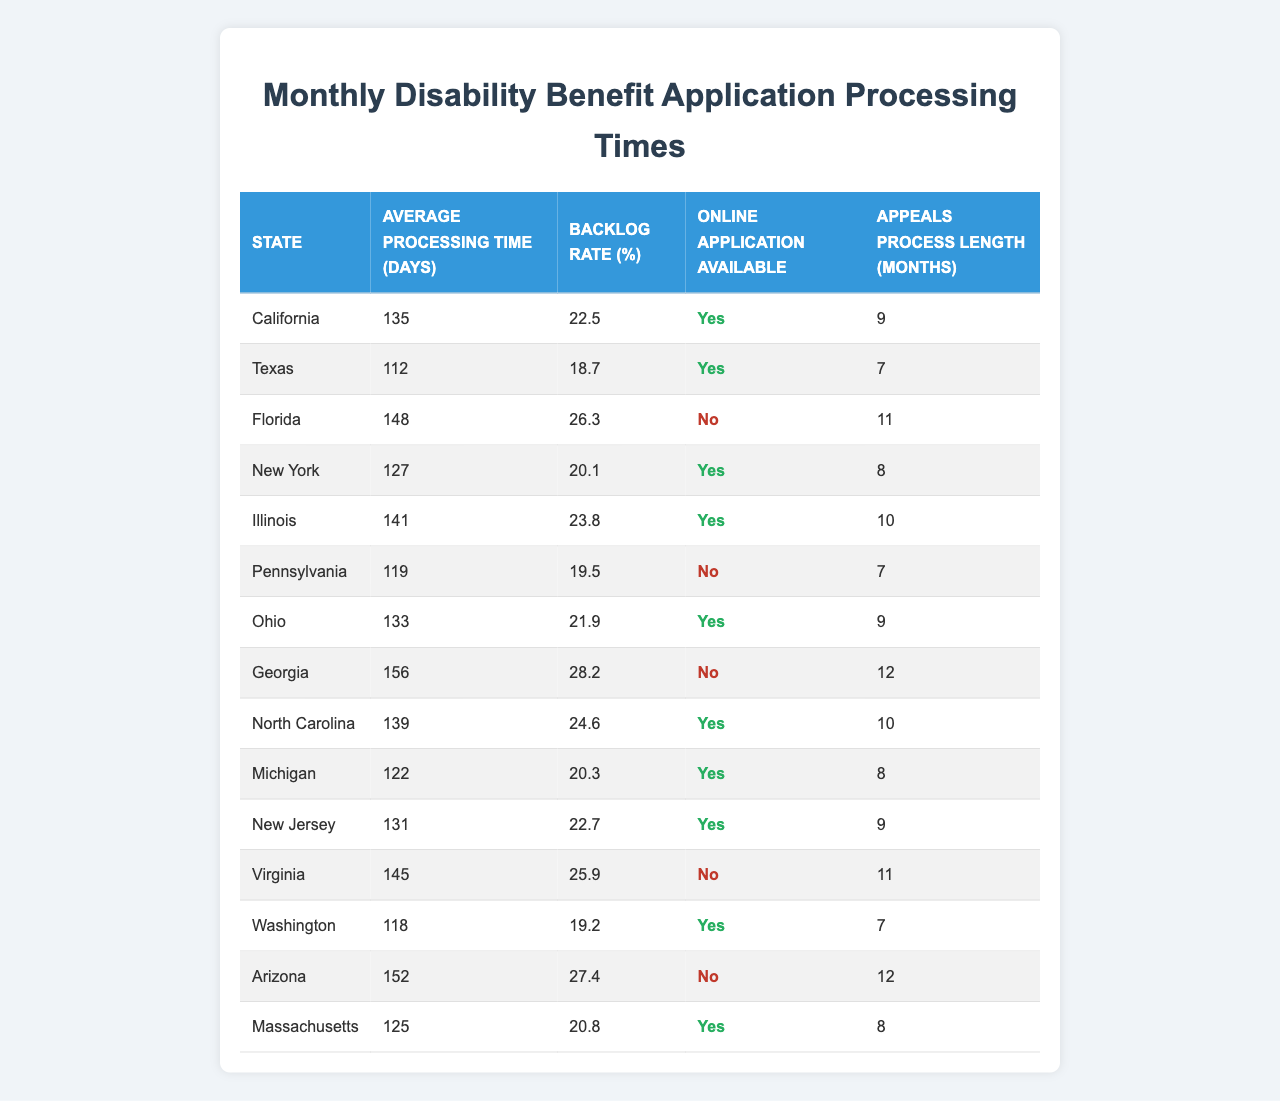What is the state with the longest average processing time? Looking at the "Average Processing Time (Days)" column, Florida has the highest value at 148 days, which is greater than all other states listed.
Answer: Florida Which state has the shortest processing time and what is it? Pennsylvania has the shortest average processing time at 119 days when compared to all other states in the table.
Answer: 119 Is online application available in Michigan? Referring to the "Online Application Available" column, Michigan's value is true, meaning the online application is indeed available.
Answer: Yes What is the backlog rate for Georgia? Georgia's backlog rate is listed as 28.2%, as indicated in the corresponding "Backlog Rate (%)" column.
Answer: 28.2% Which two states have an average processing time greater than 140 days? The states with average processing times greater than 140 days are California (135 days) and Georgia (156 days). So, the answer includes both of these states together.
Answer: California and Georgia How many states have online applications available? By examining the "Online Application Available" column, we can count the number of true entries, which are California, Texas, New York, Illinois, Ohio, Michigan, New Jersey, and Washington. This counts to 8 states.
Answer: 8 What is the average backlog rate for states without online applications? Summing the backlog rates of states without online applications (Florida at 26.3%, Pennsylvania at 19.5%, Georgia at 28.2%, Virginia at 25.9%, and Arizona at 27.4%) gives 126.3%. There are 5 states, so dividing 126.3% by 5 results in an average of 25.26%.
Answer: 25.26% Which state has the longest appeals process, and how long is it? Looking at the "Appeals Process Length (Months)" column, Georgia has the longest appeals process at 12 months when compared to all other states.
Answer: Georgia, 12 months Is the processing time in Ohio above or below the median of all states? First, we find the median of the average processing times. Arranging them in order: 112 (Texas), 118 (Washington), 119 (Pennsylvania), 122 (Michigan), 125 (Massachusetts), 127 (New York), 133 (Ohio), 135 (California), 141 (Illinois), 145 (Virginia), 148 (Florida), 152 (Arizona), 156 (Georgia). The median is the average of the 6th and 7th values: (127 + 133) / 2 = 130. Ohio's processing time at 133 is above the median.
Answer: Above the median What is the difference between the average processing time of California and Texas? The average processing time in California is 135 days and in Texas, it is 112 days. Therefore, the difference is 135 - 112 = 23 days.
Answer: 23 days 